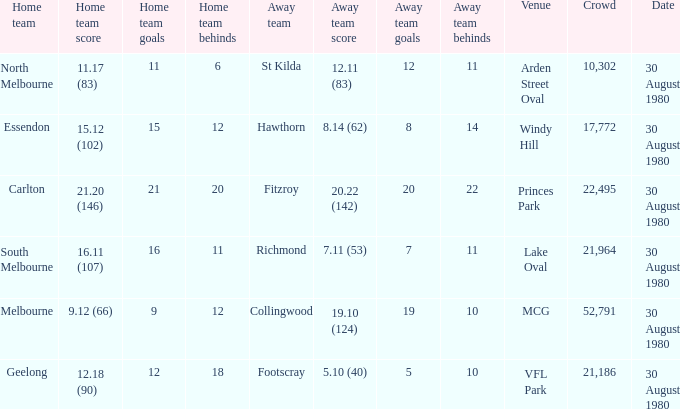What was the crowd when the away team is footscray? 21186.0. Would you mind parsing the complete table? {'header': ['Home team', 'Home team score', 'Home team goals', 'Home team behinds', 'Away team', 'Away team score', 'Away team goals', 'Away team behinds', 'Venue', 'Crowd', 'Date'], 'rows': [['North Melbourne', '11.17 (83)', '11', '6', 'St Kilda', '12.11 (83)', '12', '11', 'Arden Street Oval', '10,302', '30 August 1980'], ['Essendon', '15.12 (102)', '15', '12', 'Hawthorn', '8.14 (62)', '8', '14', 'Windy Hill', '17,772', '30 August 1980'], ['Carlton', '21.20 (146)', '21', '20', 'Fitzroy', '20.22 (142)', '20', '22', 'Princes Park', '22,495', '30 August 1980'], ['South Melbourne', '16.11 (107)', '16', '11', 'Richmond', '7.11 (53)', '7', '11', 'Lake Oval', '21,964', '30 August 1980'], ['Melbourne', '9.12 (66)', '9', '12', 'Collingwood', '19.10 (124)', '19', '10', 'MCG', '52,791', '30 August 1980'], ['Geelong', '12.18 (90)', '12', '18', 'Footscray', '5.10 (40)', '5', '10', 'VFL Park', '21,186', '30 August 1980']]} 